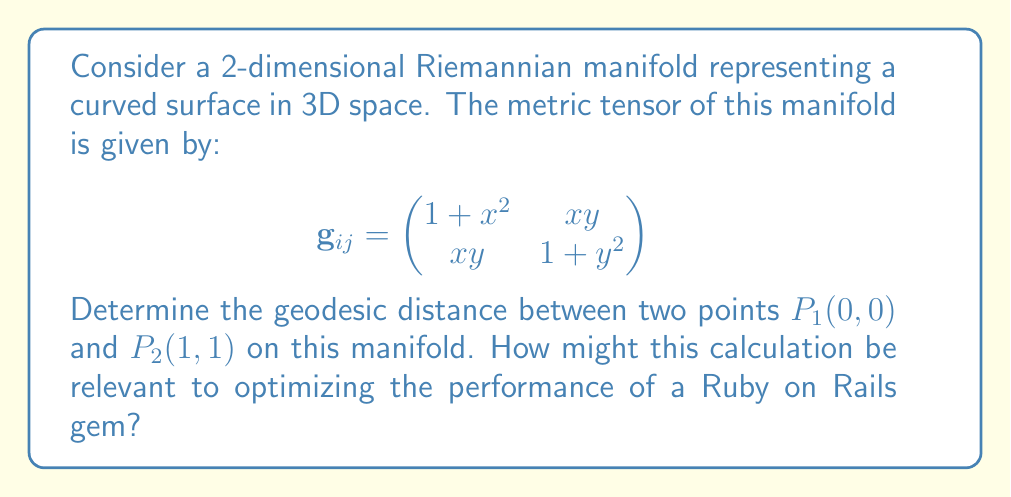Teach me how to tackle this problem. To solve this problem, we'll follow these steps:

1) The geodesic distance between two points on a Riemannian manifold is given by the minimum length of all possible curves connecting these points. This length is calculated using the line integral:

   $$L = \int_0^1 \sqrt{g_{ij}\frac{dx^i}{dt}\frac{dx^j}{dt}}dt$$

2) For our manifold, we need to parameterize the curve. Let's use a simple linear parameterization:
   
   $x(t) = t$, $y(t) = t$, where $0 \leq t \leq 1$

3) Now, we calculate $\frac{dx}{dt} = 1$ and $\frac{dy}{dt} = 1$

4) Substituting into the line integral:

   $$L = \int_0^1 \sqrt{g_{11}(\frac{dx}{dt})^2 + 2g_{12}\frac{dx}{dt}\frac{dy}{dt} + g_{22}(\frac{dy}{dt})^2}dt$$

5) Inserting the metric tensor components:

   $$L = \int_0^1 \sqrt{(1+t^2)(1)^2 + 2(t^2)(1)(1) + (1+t^2)(1)^2}dt$$

6) Simplifying:

   $$L = \int_0^1 \sqrt{2 + 4t^2}dt$$

7) This integral can be solved using substitution. Let $u = 2 + 4t^2$, then $du = 8tdt$, or $dt = \frac{du}{8t}$:

   $$L = \frac{1}{4}\int_2^6 \frac{\sqrt{u}}{\sqrt{u-2}}du$$

8) This integral results in:

   $$L = \frac{1}{4}[\sqrt{u(u-2)} + 2\ln(\sqrt{u} + \sqrt{u-2})]_2^6$$

9) Evaluating the limits:

   $$L = \frac{1}{4}[\sqrt{6(4)} + 2\ln(\sqrt{6} + \sqrt{4}) - (\sqrt{2(0)} + 2\ln(\sqrt{2} + \sqrt{0}))]$$

10) Simplifying:

    $$L = \frac{1}{4}[\sqrt{24} + 2\ln(\sqrt{6} + 2) - 2\ln(\sqrt{2})]$$

This geodesic distance calculation is relevant to optimizing Ruby on Rails gems because it represents the shortest path between two points in a curved space. In the context of optimization algorithms, this could be analogous to finding the most efficient path between two states in a complex system, such as minimizing database queries or optimizing routing in a web application.
Answer: $\frac{1}{4}[\sqrt{24} + 2\ln(\sqrt{6} + 2) - 2\ln(\sqrt{2})]$ 